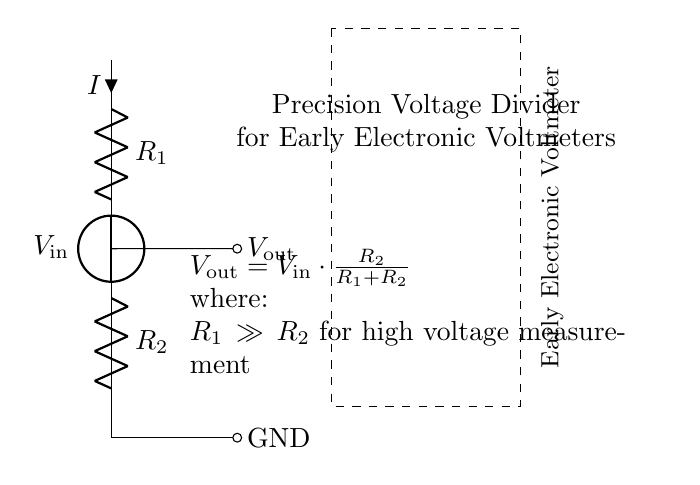What is the input voltage represented in the circuit? The circuit diagram indicates that the input voltage is labeled as V_in. This is typically the source voltage applied across the voltage divider, specifically shown as the voltage source on the top left of the diagram.
Answer: V_in What are the two resistor values in the circuit? The circuit contains two resistors labeled R_1 and R_2. These values are crucial in determining the output voltage based on the voltage divider rule.
Answer: R_1 and R_2 What is the output voltage formula depicted in the circuit? The output voltage is given by the formula V_out = V_in * (R_2 / (R_1 + R_2)). This equation shows how the output voltage is derived from the input voltage and the resistor values.
Answer: V_out = V_in * (R_2 / (R_1 + R_2)) Why is R_1 much greater than R_2 in high voltage measurements? In voltage divider circuits designed for high voltage measurements, it is necessary for R_1 to be much greater than R_2 to ensure that the majority of the voltage drop occurs across R_1, allowing for a safer measurement of V_out, which is a fraction of V_in.
Answer: R_1 >> R_2 What does the output voltage depend on in this circuit? The output voltage depends on the ratio of the resistors R_1 and R_2 as well as the input voltage V_in. The output is specifically a fraction of the input voltage influenced by these resistors.
Answer: R_1 and R_2 ratios What is the purpose of the voltage divider in the circuit? The voltage divider is primarily used to reduce the voltage in order to measure high input voltages accurately. This allows electronic voltmeters to provide sensible readings without exceeding their voltage rating.
Answer: Measure high voltages What can be inferred about the connection to ground in this circuit? The connection to ground is a reference point for the output voltage measurement, which provides a stable baseline. This is essential for accurate voltage readings when measuring V_out.
Answer: Reference point for measurement 